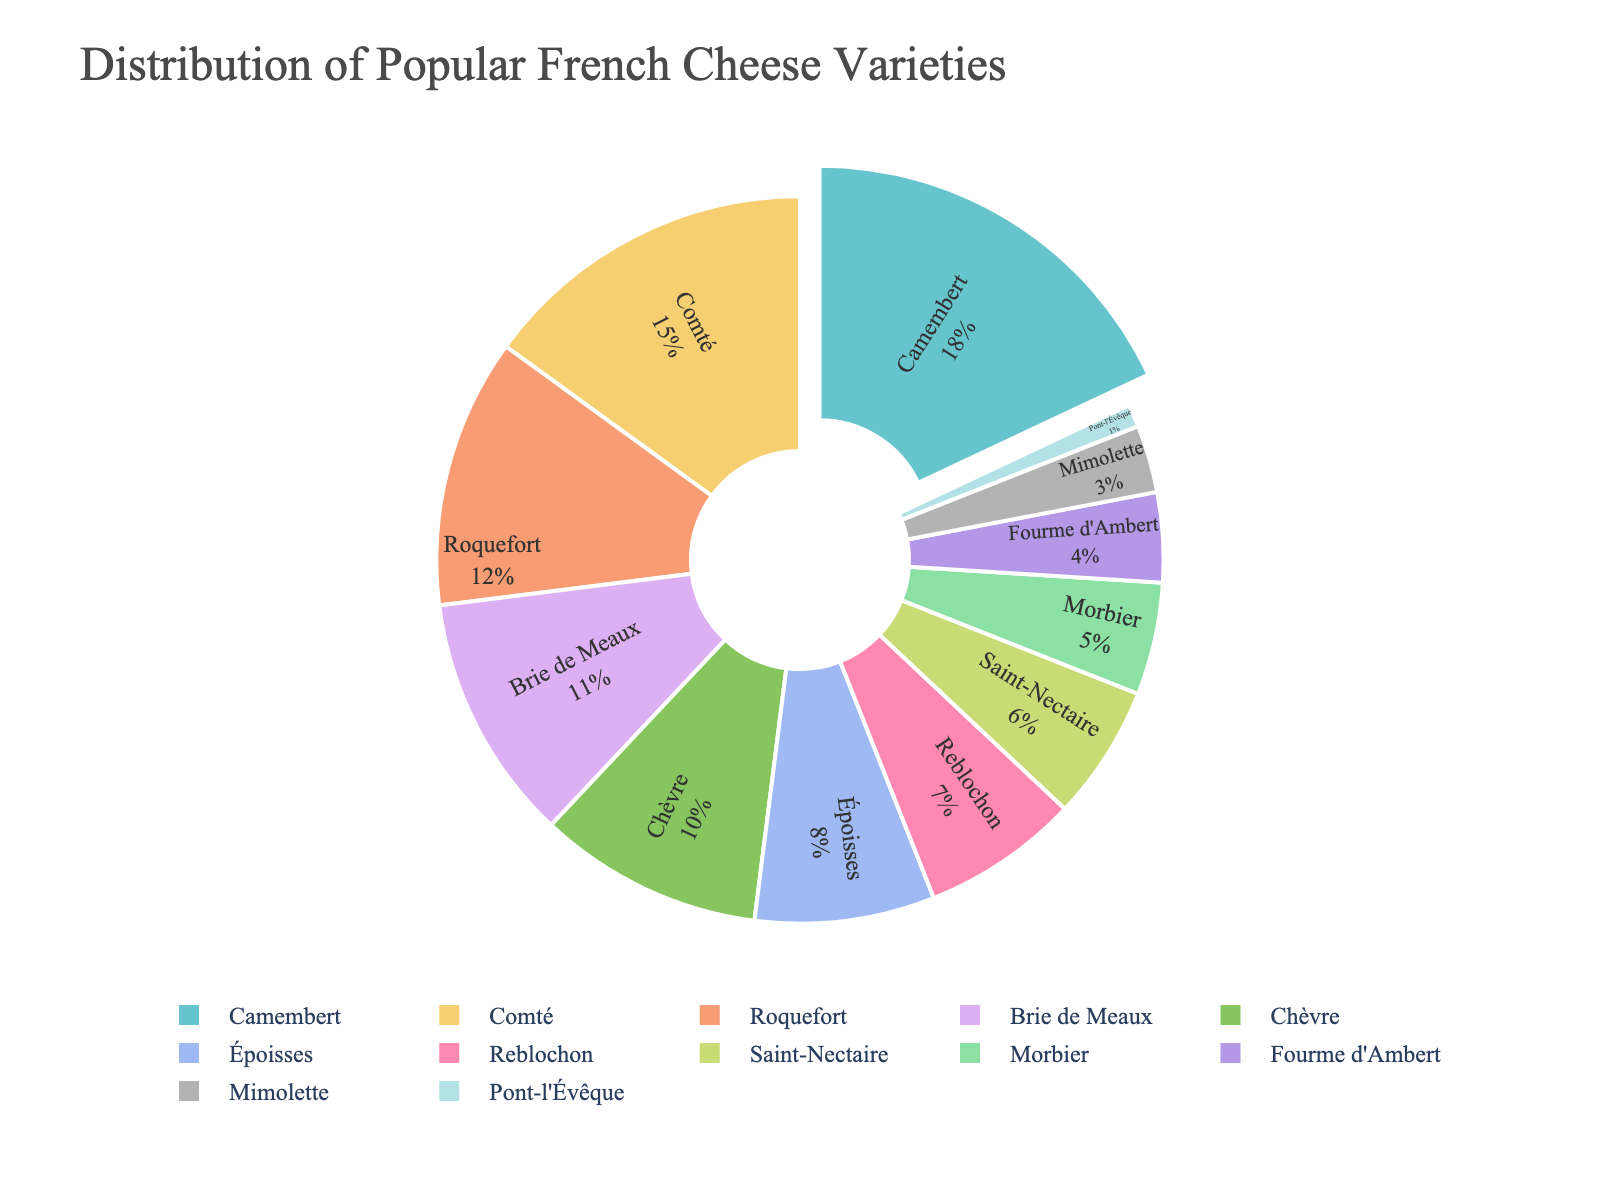Which cheese variety has the highest percentage in the distribution? According to the pie chart, the cheese variety with the largest slice is Camembert, which holds the highest percentage.
Answer: Camembert What is the combined percentage of Roquefort and Brie de Meaux? From the chart, Roquefort has 12% and Brie de Meaux has 11%. Adding these together gives 12% + 11% = 23%.
Answer: 23% Which cheese variety has the smallest percentage in the distribution? The smallest slice in the pie chart belongs to Pont-l'Évêque, which has the lowest percentage.
Answer: Pont-l'Évêque How many cheese varieties have a percentage greater than or equal to 10%? From the pie chart, Camembert (18%), Comté (15%), Roquefort (12%), Brie de Meaux (11%), and Chèvre (10%) all have percentages greater than or equal to 10%. Counting these, we get 5 varieties.
Answer: 5 Which cheese varieties have a combined percentage less than Comté? From the chart, Comté is 15%. Summing the percentages of Saint-Nectaire (6%), Morbier (5%), Fourme d'Ambert (4%), Mimolette (3%), and Pont-l'Évêque (1%) totals to 6% + 5% + 4% + 3% + 1% = 19%. Therefore, individually, Saint-Nectaire, Morbier, Fourme d'Ambert, Mimolette, and Pont-l'Évêque each have combinations less than 15%.
Answer: Saint-Nectaire, Morbier, Fourme d'Ambert, Mimolette, Pont-l'Évêque By how much does Camembert exceed the percentage of Reblochon? From the chart, Camembert is 18% and Reblochon is 7%. The difference is 18% - 7% = 11%.
Answer: 11% Which cheese varieties together make up less than 10%? The slices for Fourme d'Ambert (4%), Mimolette (3%), and Pont-l'Évêque (1%) together sum up to 4% + 3% + 1% = 8%. Therefore, these varieties collectively make up less than 10% in the distribution.
Answer: Fourme d'Ambert, Mimolette, Pont-l'Évêque How does the percentage of Chèvre compare to that of Époisses? The chart shows Chèvre at 10% and Époisses at 8%. Comparing these, Chèvre has a higher percentage by 2%.
Answer: Chèvre has 2% more What is the total percentage for the top three cheese varieties? According to the chart, Camembert (18%), Comté (15%), and Roquefort (12%) are the top three. Summing these gives 18% + 15% + 12% = 45%.
Answer: 45% 